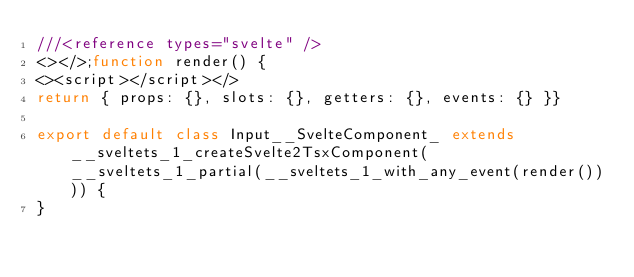Convert code to text. <code><loc_0><loc_0><loc_500><loc_500><_TypeScript_>///<reference types="svelte" />
<></>;function render() {
<><script></script></>
return { props: {}, slots: {}, getters: {}, events: {} }}

export default class Input__SvelteComponent_ extends __sveltets_1_createSvelte2TsxComponent(__sveltets_1_partial(__sveltets_1_with_any_event(render()))) {
}</code> 